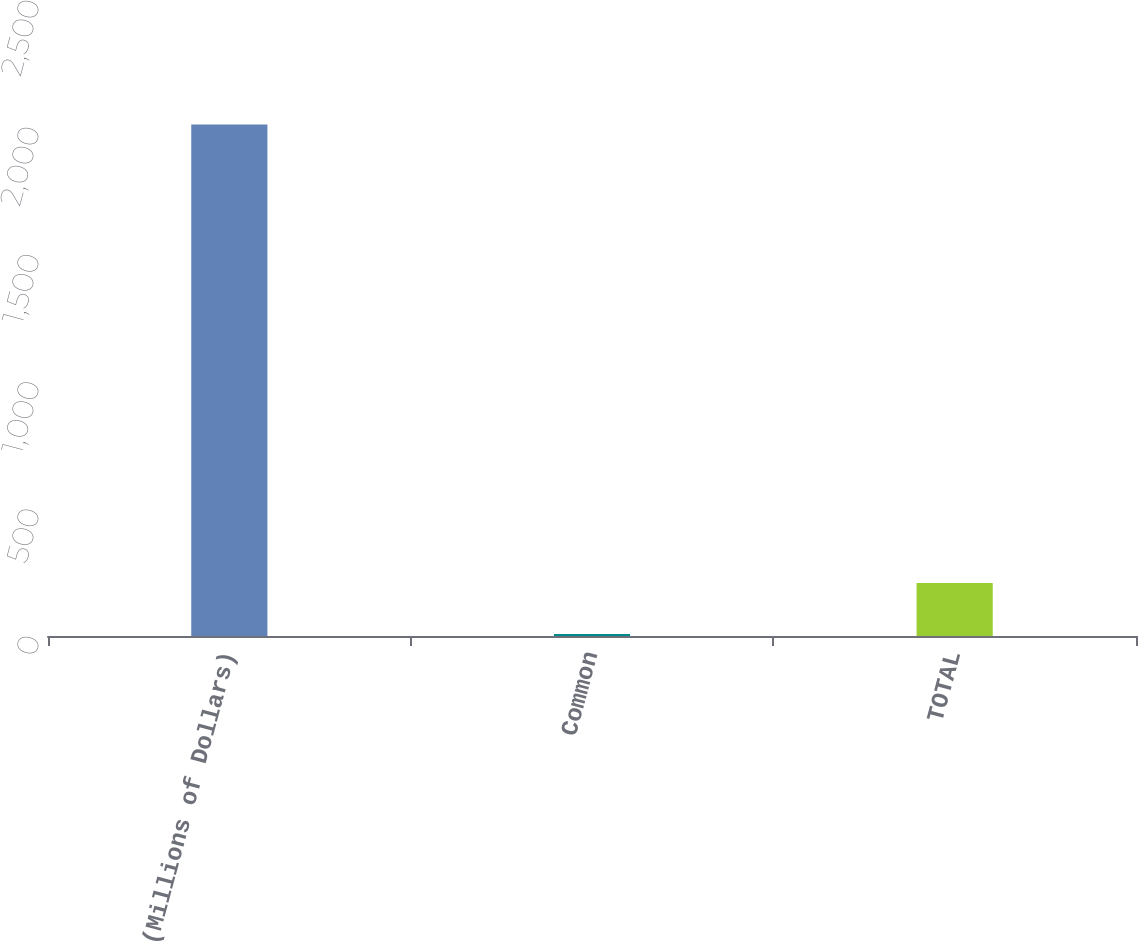<chart> <loc_0><loc_0><loc_500><loc_500><bar_chart><fcel>(Millions of Dollars)<fcel>Common<fcel>TOTAL<nl><fcel>2011<fcel>8<fcel>208.3<nl></chart> 